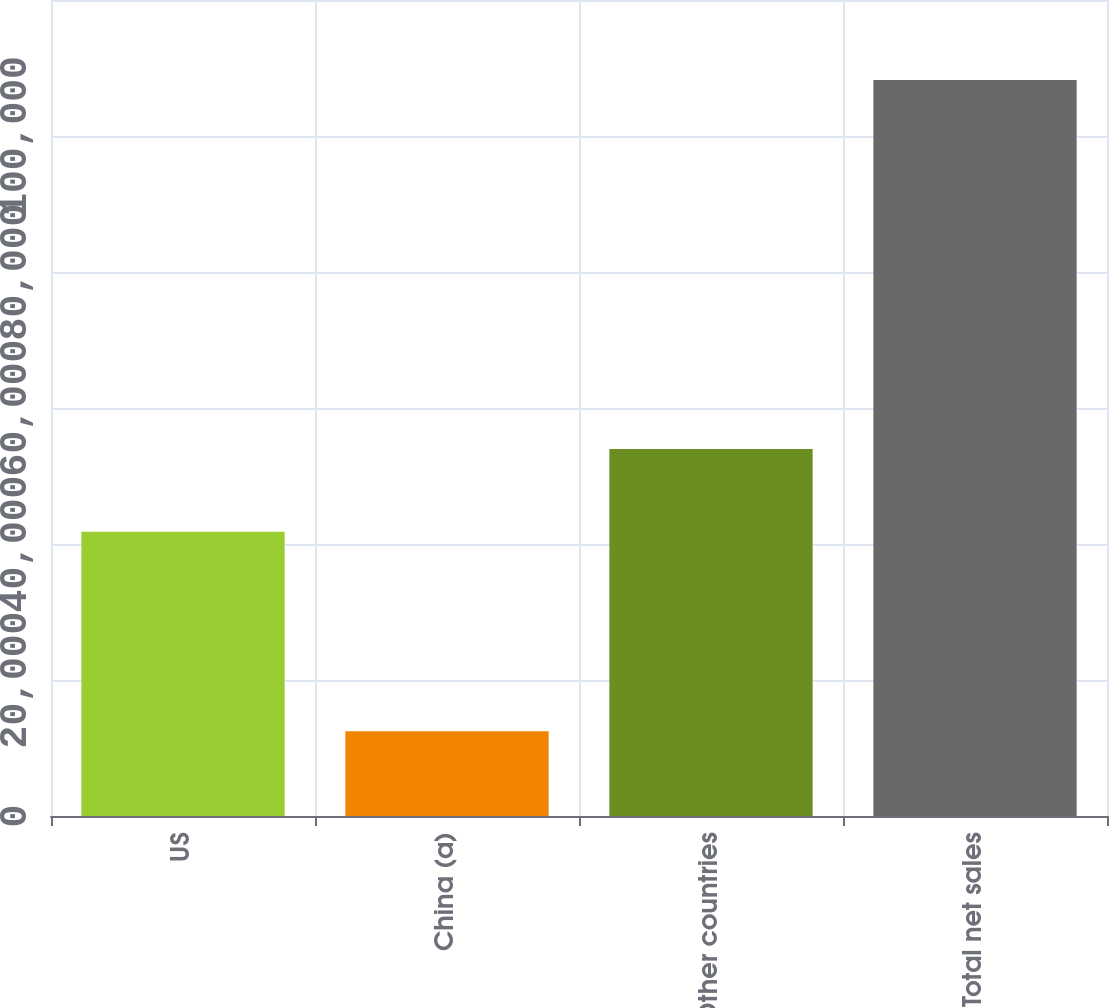<chart> <loc_0><loc_0><loc_500><loc_500><bar_chart><fcel>US<fcel>China (a)<fcel>Other countries<fcel>Total net sales<nl><fcel>41812<fcel>12472<fcel>53965<fcel>108249<nl></chart> 